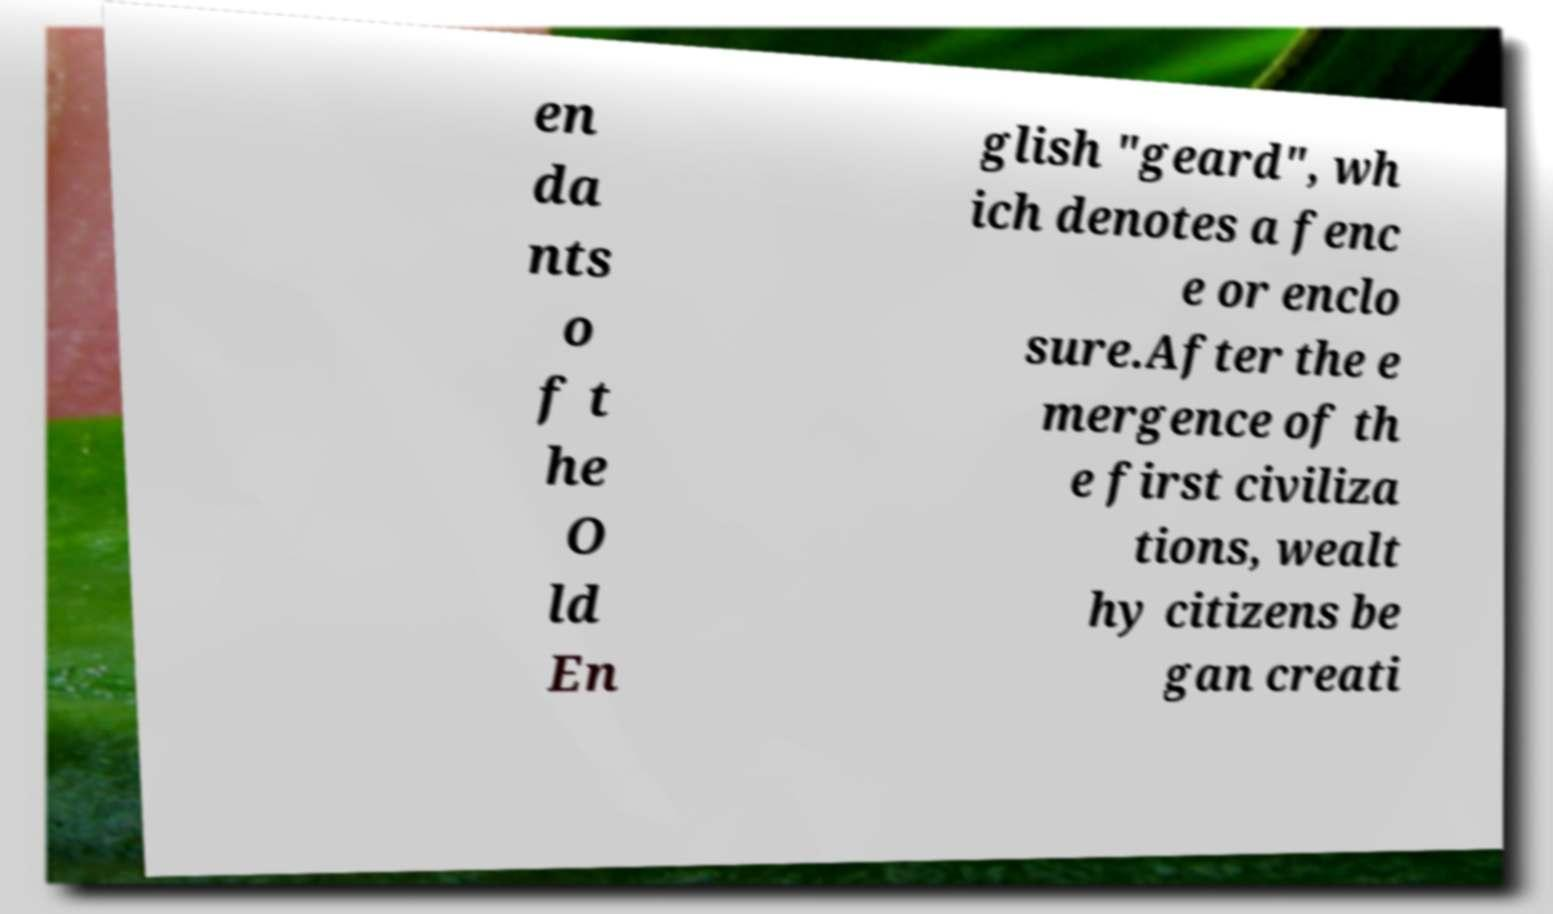Please identify and transcribe the text found in this image. en da nts o f t he O ld En glish "geard", wh ich denotes a fenc e or enclo sure.After the e mergence of th e first civiliza tions, wealt hy citizens be gan creati 